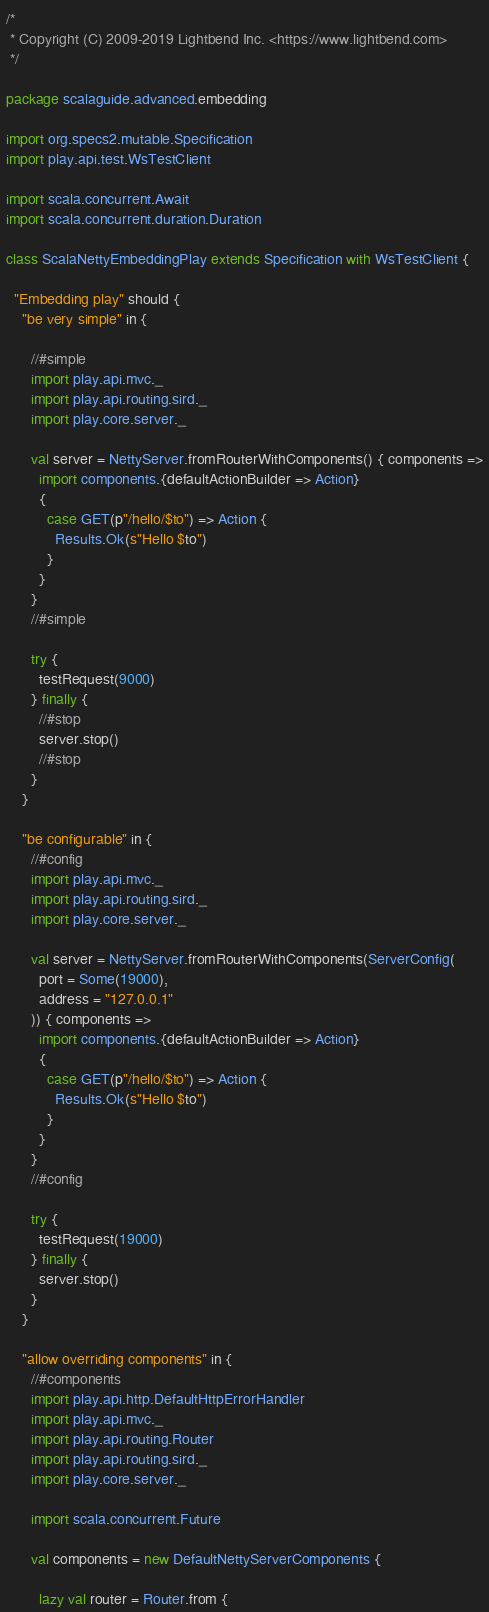<code> <loc_0><loc_0><loc_500><loc_500><_Scala_>/*
 * Copyright (C) 2009-2019 Lightbend Inc. <https://www.lightbend.com>
 */

package scalaguide.advanced.embedding

import org.specs2.mutable.Specification
import play.api.test.WsTestClient

import scala.concurrent.Await
import scala.concurrent.duration.Duration

class ScalaNettyEmbeddingPlay extends Specification with WsTestClient {

  "Embedding play" should {
    "be very simple" in {

      //#simple
      import play.api.mvc._
      import play.api.routing.sird._
      import play.core.server._

      val server = NettyServer.fromRouterWithComponents() { components =>
        import components.{defaultActionBuilder => Action}
        {
          case GET(p"/hello/$to") => Action {
            Results.Ok(s"Hello $to")
          }
        }
      }
      //#simple

      try {
        testRequest(9000)
      } finally {
        //#stop
        server.stop()
        //#stop
      }
    }

    "be configurable" in {
      //#config
      import play.api.mvc._
      import play.api.routing.sird._
      import play.core.server._

      val server = NettyServer.fromRouterWithComponents(ServerConfig(
        port = Some(19000),
        address = "127.0.0.1"
      )) { components =>
        import components.{defaultActionBuilder => Action}
        {
          case GET(p"/hello/$to") => Action {
            Results.Ok(s"Hello $to")
          }
        }
      }
      //#config

      try {
        testRequest(19000)
      } finally {
        server.stop()
      }
    }

    "allow overriding components" in {
      //#components
      import play.api.http.DefaultHttpErrorHandler
      import play.api.mvc._
      import play.api.routing.Router
      import play.api.routing.sird._
      import play.core.server._

      import scala.concurrent.Future

      val components = new DefaultNettyServerComponents {

        lazy val router = Router.from {</code> 